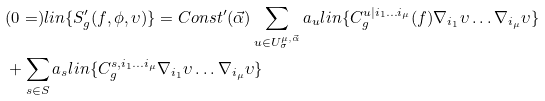Convert formula to latex. <formula><loc_0><loc_0><loc_500><loc_500>& ( 0 = ) l i n \{ S ^ { \prime } _ { g } ( f , \phi , \upsilon ) \} = C o n s t ^ { \prime } ( \vec { \alpha } ) \sum _ { u \in U ^ { \mu , \vec { \alpha } } _ { \sigma } } a _ { u } l i n \{ C ^ { u | i _ { 1 } \dots i _ { \mu } } _ { g } ( f ) \nabla _ { i _ { 1 } } \upsilon \dots \nabla _ { i _ { \mu } } \upsilon \} \\ & + \sum _ { s \in S } a _ { s } l i n \{ C ^ { s , i _ { 1 } \dots i _ { \mu } } _ { g } \nabla _ { i _ { 1 } } \upsilon \dots \nabla _ { i _ { \mu } } \upsilon \}</formula> 